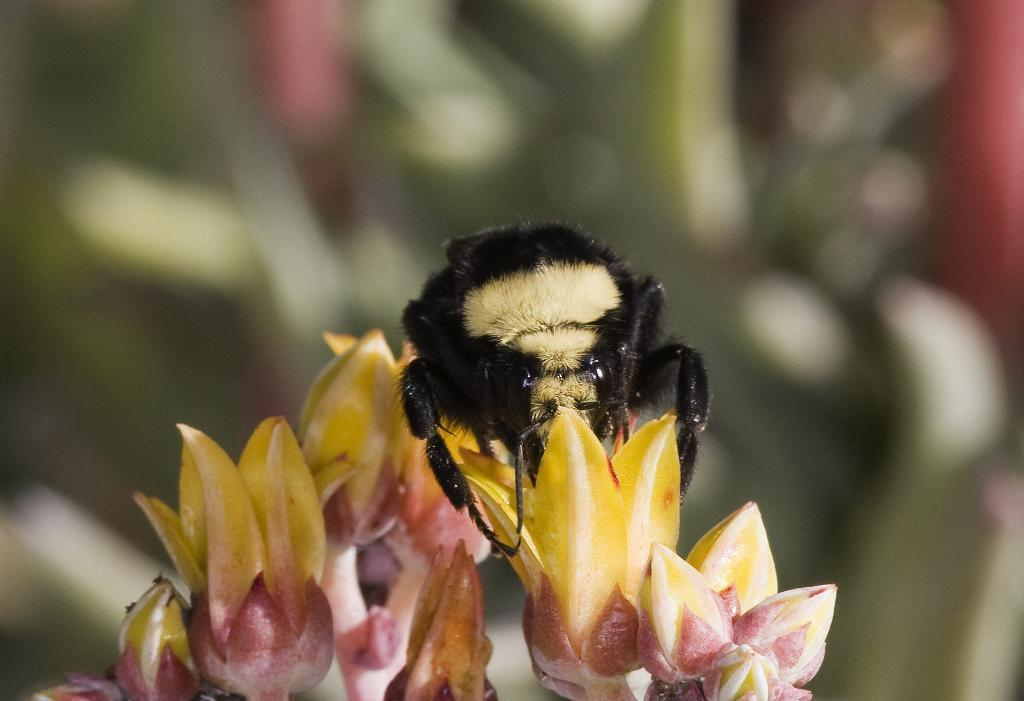What type of living organisms can be seen in the image? There are flowers in the image. Can you describe the stage of growth for some of the flowers? Yes, there are buds in the image. What other living organism can be seen in the image? There is an insect on a flower in the image. How would you describe the background of the image? The background of the image is blurred. What type of wood can be seen in the image? There is no wood present in the image. What color is the sock on the insect in the image? There is no sock present in the image, and the insect does not have any clothing. 